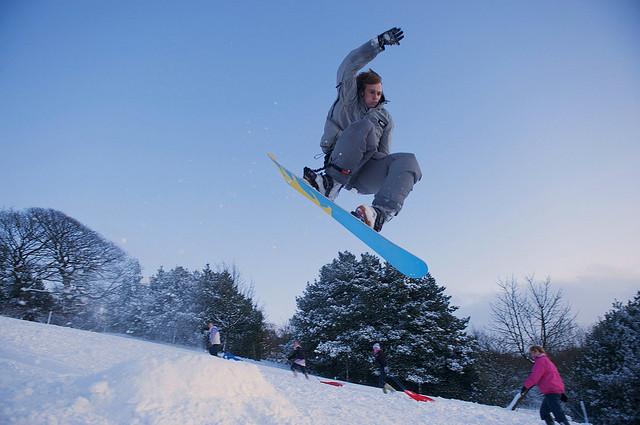What are on this person's feet?
Concise answer only. Boots. Do the trees look extra tall?
Answer briefly. No. Is this person touching the ground?
Write a very short answer. No. What color is the underside of the snowboard?
Short answer required. Blue. What color is the snowboard?
Short answer required. Blue. Could they be skiing together?
Write a very short answer. Yes. What is the girl in pink doing?
Concise answer only. Snowboarding. 